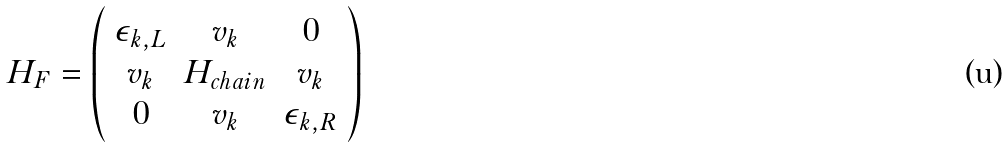<formula> <loc_0><loc_0><loc_500><loc_500>H _ { F } = \left ( \begin{array} { c c c } \epsilon _ { k , L } & v _ { k } & 0 \\ v _ { k } & H _ { c h a i n } & v _ { k } \\ 0 & v _ { k } & \epsilon _ { k , R } \\ \end{array} \right )</formula> 